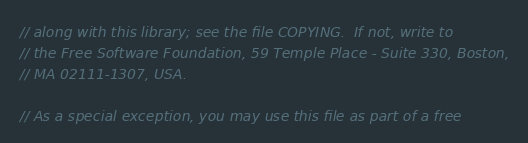<code> <loc_0><loc_0><loc_500><loc_500><_C++_>// along with this library; see the file COPYING.  If not, write to
// the Free Software Foundation, 59 Temple Place - Suite 330, Boston,
// MA 02111-1307, USA.

// As a special exception, you may use this file as part of a free</code> 